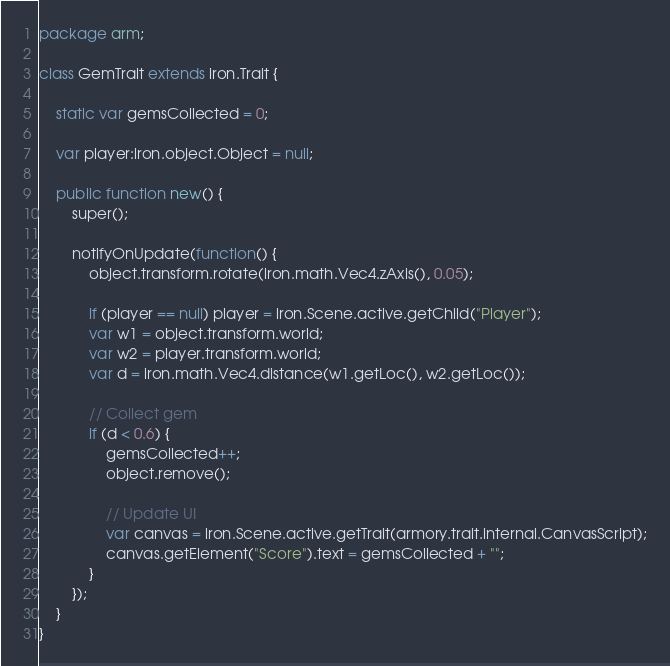Convert code to text. <code><loc_0><loc_0><loc_500><loc_500><_Haxe_>package arm;

class GemTrait extends iron.Trait {

	static var gemsCollected = 0;

	var player:iron.object.Object = null;

	public function new() {
		super();

		notifyOnUpdate(function() {
			object.transform.rotate(iron.math.Vec4.zAxis(), 0.05);

			if (player == null) player = iron.Scene.active.getChild("Player");
			var w1 = object.transform.world;
			var w2 = player.transform.world;
			var d = iron.math.Vec4.distance(w1.getLoc(), w2.getLoc());
			
			// Collect gem
			if (d < 0.6) {
				gemsCollected++;
				object.remove();

				// Update UI
				var canvas = iron.Scene.active.getTrait(armory.trait.internal.CanvasScript);
				canvas.getElement("Score").text = gemsCollected + "";
			}
		});
	}
}
</code> 